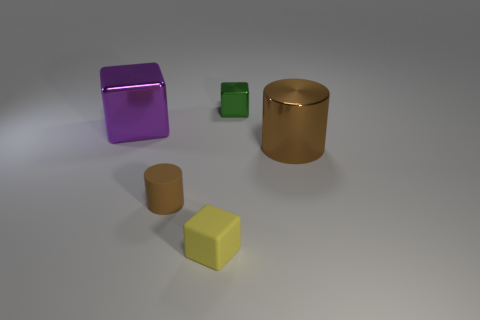Subtract all green cylinders. Subtract all purple cubes. How many cylinders are left? 2 Add 3 small green shiny objects. How many objects exist? 8 Subtract all blocks. How many objects are left? 2 Subtract 0 cyan cubes. How many objects are left? 5 Subtract all yellow objects. Subtract all cylinders. How many objects are left? 2 Add 5 brown shiny cylinders. How many brown shiny cylinders are left? 6 Add 2 purple metal cubes. How many purple metal cubes exist? 3 